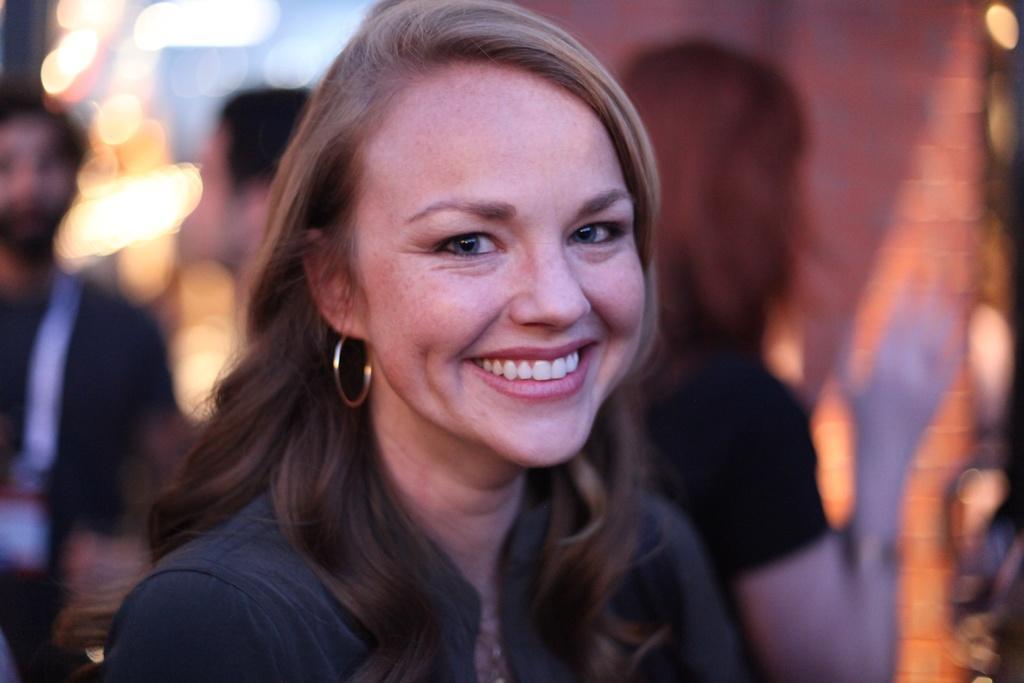Can you describe this image briefly? This picture describes about group of people, in the middle of the image we can see a woman, she is smiling, in the background we can find few lights. 